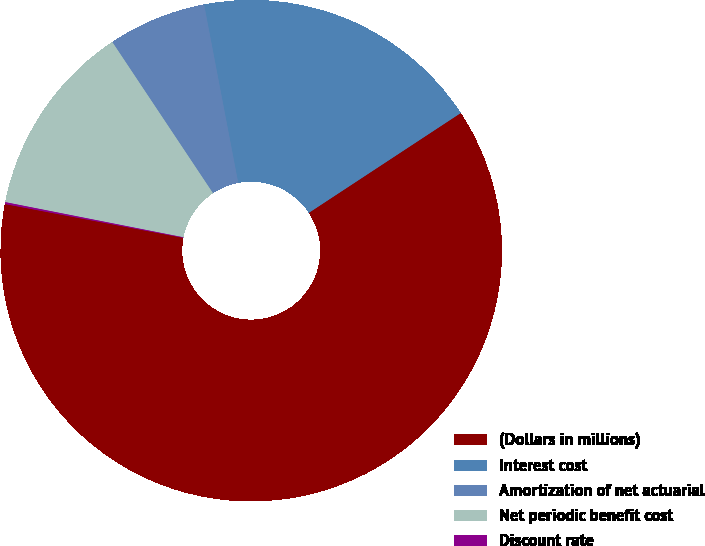<chart> <loc_0><loc_0><loc_500><loc_500><pie_chart><fcel>(Dollars in millions)<fcel>Interest cost<fcel>Amortization of net actuarial<fcel>Net periodic benefit cost<fcel>Discount rate<nl><fcel>62.24%<fcel>18.76%<fcel>6.34%<fcel>12.55%<fcel>0.12%<nl></chart> 